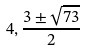Convert formula to latex. <formula><loc_0><loc_0><loc_500><loc_500>4 , \frac { 3 \pm \sqrt { 7 3 } } { 2 }</formula> 